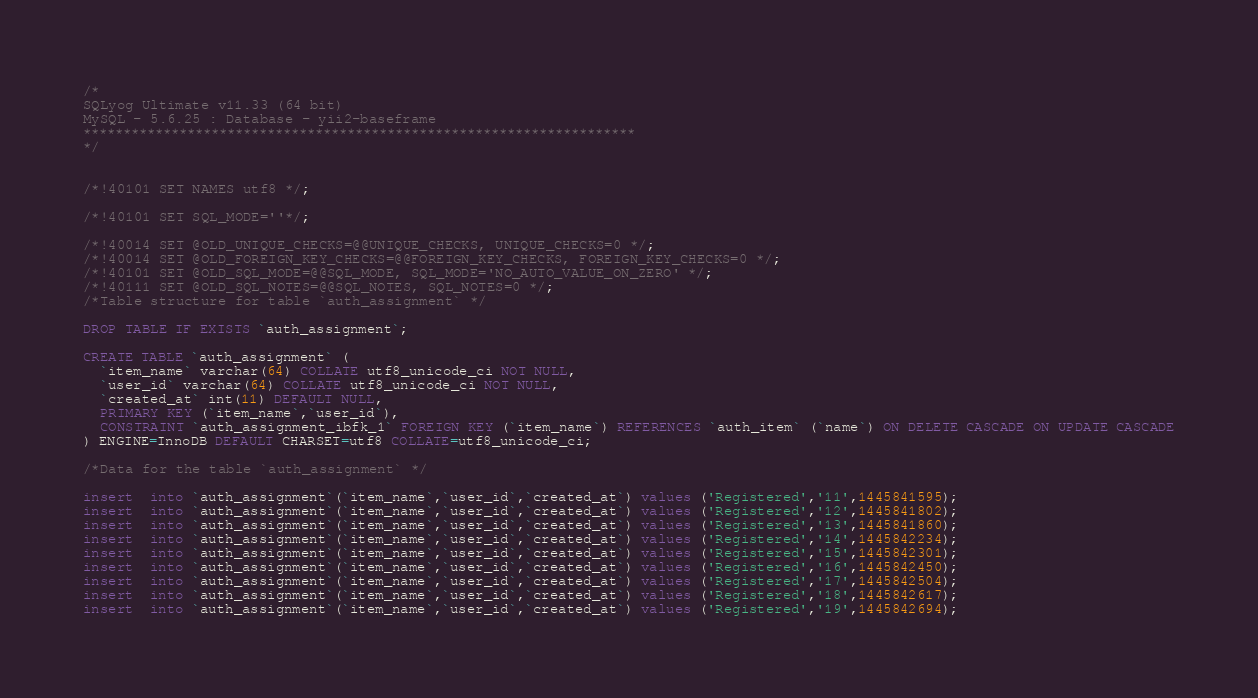<code> <loc_0><loc_0><loc_500><loc_500><_SQL_>/*
SQLyog Ultimate v11.33 (64 bit)
MySQL - 5.6.25 : Database - yii2-baseframe
*********************************************************************
*/

/*!40101 SET NAMES utf8 */;

/*!40101 SET SQL_MODE=''*/;

/*!40014 SET @OLD_UNIQUE_CHECKS=@@UNIQUE_CHECKS, UNIQUE_CHECKS=0 */;
/*!40014 SET @OLD_FOREIGN_KEY_CHECKS=@@FOREIGN_KEY_CHECKS, FOREIGN_KEY_CHECKS=0 */;
/*!40101 SET @OLD_SQL_MODE=@@SQL_MODE, SQL_MODE='NO_AUTO_VALUE_ON_ZERO' */;
/*!40111 SET @OLD_SQL_NOTES=@@SQL_NOTES, SQL_NOTES=0 */;
/*Table structure for table `auth_assignment` */

DROP TABLE IF EXISTS `auth_assignment`;

CREATE TABLE `auth_assignment` (
  `item_name` varchar(64) COLLATE utf8_unicode_ci NOT NULL,
  `user_id` varchar(64) COLLATE utf8_unicode_ci NOT NULL,
  `created_at` int(11) DEFAULT NULL,
  PRIMARY KEY (`item_name`,`user_id`),
  CONSTRAINT `auth_assignment_ibfk_1` FOREIGN KEY (`item_name`) REFERENCES `auth_item` (`name`) ON DELETE CASCADE ON UPDATE CASCADE
) ENGINE=InnoDB DEFAULT CHARSET=utf8 COLLATE=utf8_unicode_ci;

/*Data for the table `auth_assignment` */

insert  into `auth_assignment`(`item_name`,`user_id`,`created_at`) values ('Registered','11',1445841595);
insert  into `auth_assignment`(`item_name`,`user_id`,`created_at`) values ('Registered','12',1445841802);
insert  into `auth_assignment`(`item_name`,`user_id`,`created_at`) values ('Registered','13',1445841860);
insert  into `auth_assignment`(`item_name`,`user_id`,`created_at`) values ('Registered','14',1445842234);
insert  into `auth_assignment`(`item_name`,`user_id`,`created_at`) values ('Registered','15',1445842301);
insert  into `auth_assignment`(`item_name`,`user_id`,`created_at`) values ('Registered','16',1445842450);
insert  into `auth_assignment`(`item_name`,`user_id`,`created_at`) values ('Registered','17',1445842504);
insert  into `auth_assignment`(`item_name`,`user_id`,`created_at`) values ('Registered','18',1445842617);
insert  into `auth_assignment`(`item_name`,`user_id`,`created_at`) values ('Registered','19',1445842694);</code> 